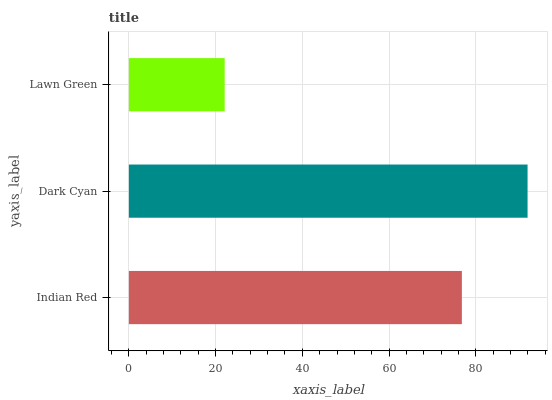Is Lawn Green the minimum?
Answer yes or no. Yes. Is Dark Cyan the maximum?
Answer yes or no. Yes. Is Dark Cyan the minimum?
Answer yes or no. No. Is Lawn Green the maximum?
Answer yes or no. No. Is Dark Cyan greater than Lawn Green?
Answer yes or no. Yes. Is Lawn Green less than Dark Cyan?
Answer yes or no. Yes. Is Lawn Green greater than Dark Cyan?
Answer yes or no. No. Is Dark Cyan less than Lawn Green?
Answer yes or no. No. Is Indian Red the high median?
Answer yes or no. Yes. Is Indian Red the low median?
Answer yes or no. Yes. Is Dark Cyan the high median?
Answer yes or no. No. Is Lawn Green the low median?
Answer yes or no. No. 